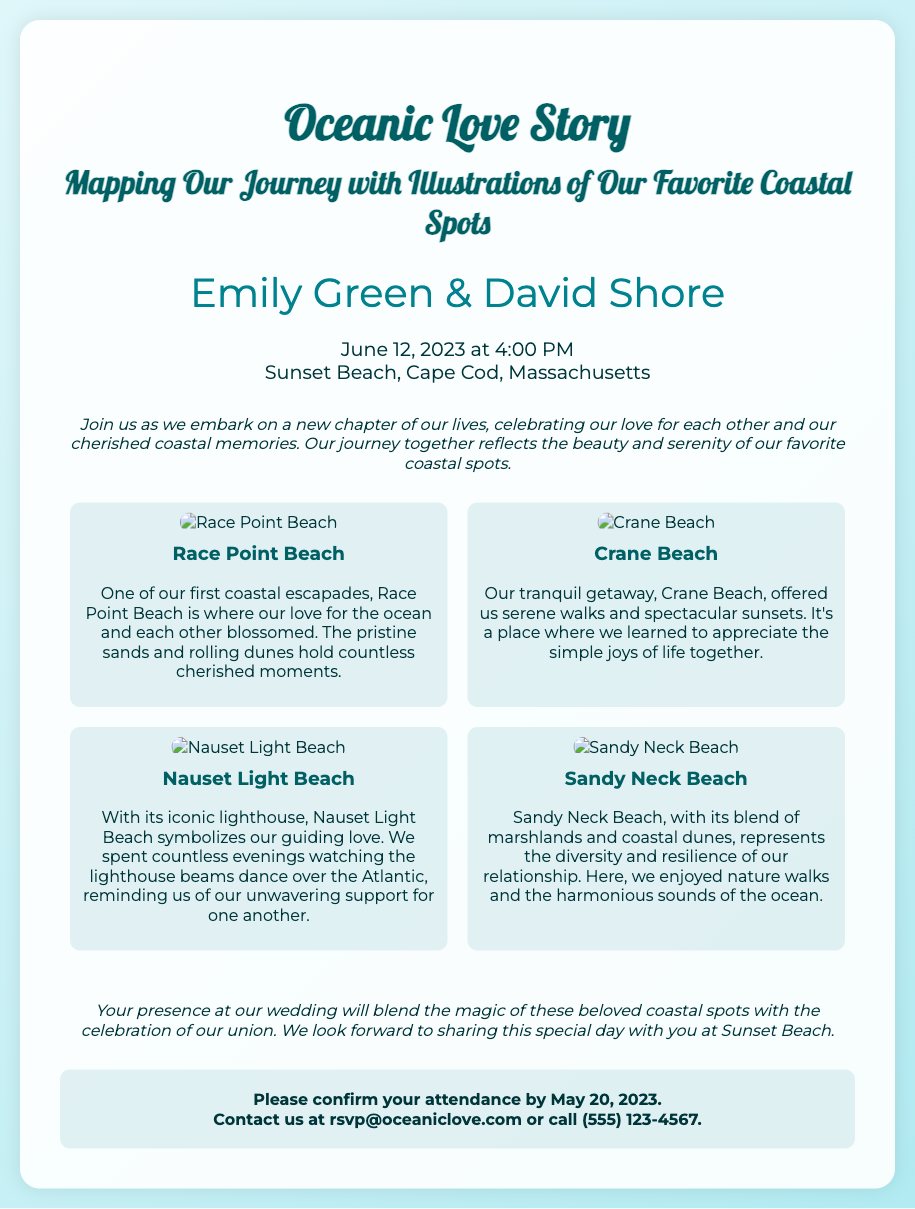what are the names of the couple? The names of the couple are found in the "couple-names" section of the document.
Answer: Emily Green & David Shore when is the wedding date? The wedding date is specified in the "event-details" section of the document.
Answer: June 12, 2023 where is the wedding taking place? The location of the wedding is mentioned in the "event-details" section of the document.
Answer: Sunset Beach, Cape Cod, Massachusetts how many favorite coastal spots are illustrated? The document lists the favorite coastal spots in a section, counting them gives the total.
Answer: Four what does Nauset Light Beach symbolize for the couple? The symbolism of Nauset Light Beach is explained in its description, providing insight into the couple's relationship.
Answer: Guiding love which coastal spot is described as a tranquil getaway? The description of each coastal spot includes key phrases that identify them, specifically looking for "tranquil."
Answer: Crane Beach by when should guests confirm their attendance? The RSVP deadline is clearly stated in the "rsvp" section of the document.
Answer: May 20, 2023 what type of event is being described in the document? The overall theme of the document reveals the nature of the occasion being highlighted.
Answer: Wedding what is the contact method provided for RSVPs? The "rsvp" section gives contact details for guests to confirm their attendance.
Answer: Email or phone call 